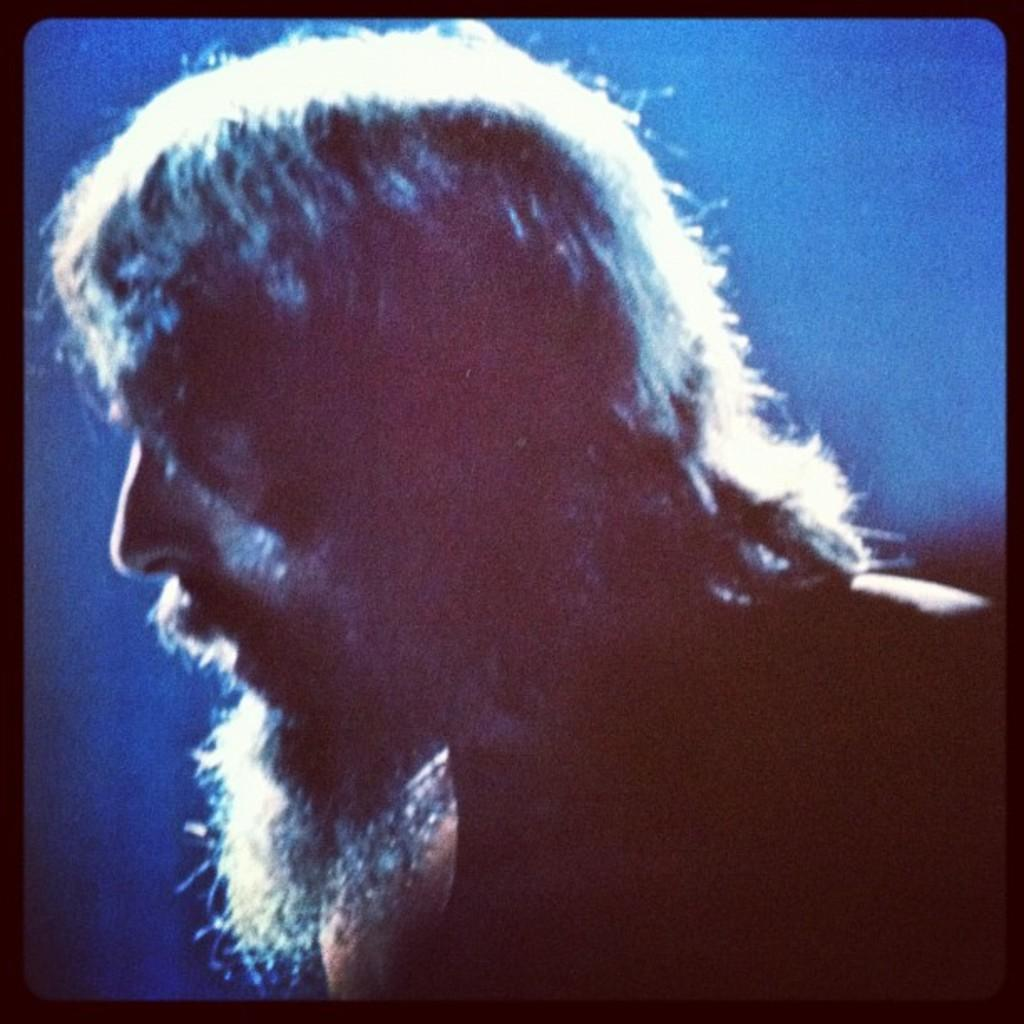Who is the main subject of the image? There is a picture of a man in the image. What can be observed about the man's facial hair? The man has a white beard. What can be observed about the man's hair? The man has white hair. What color is the background of the image? The background of the image is blue in color. How many books can be seen on the man's leather linen in the image? There are no books or leather linen present in the image; it features a picture of a man with a white beard and white hair against a blue background. 